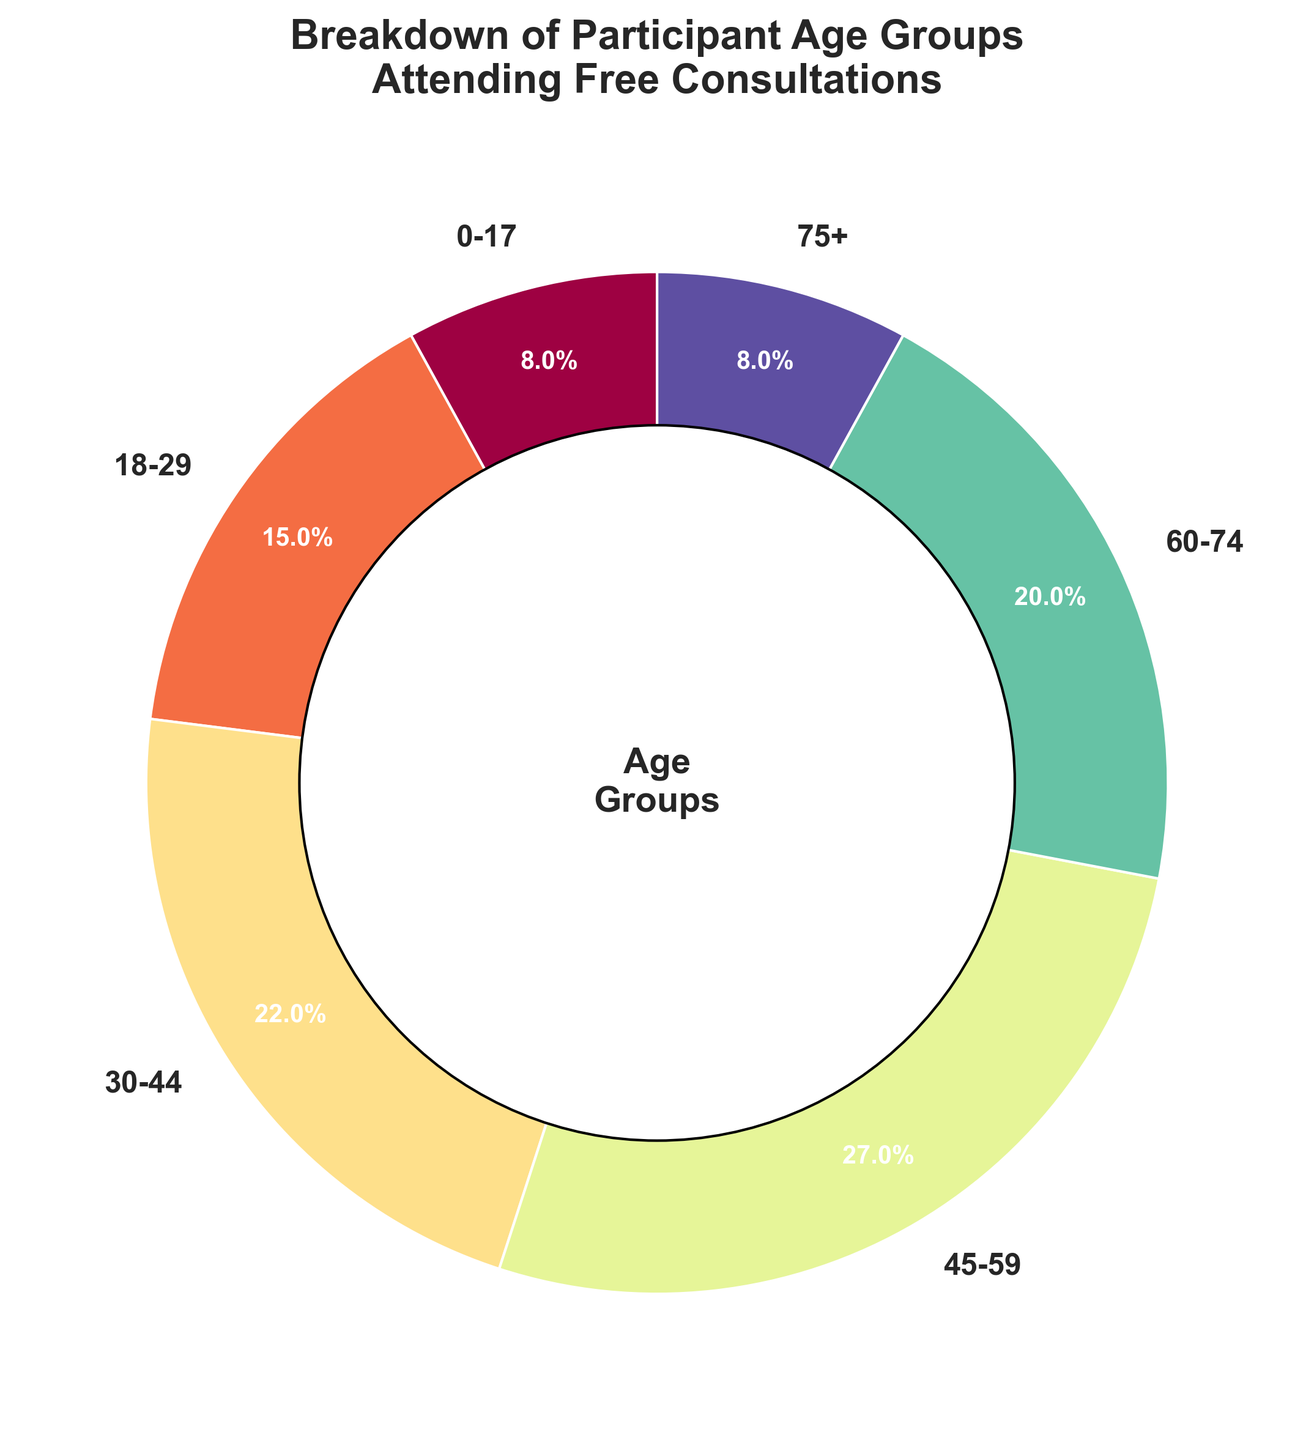What percentage of participants are under 30 years old? Sum the percentages of age groups 0-17 and 18-29. The calculation is 8% + 15% = 23%.
Answer: 23% Which age group has the highest percentage of participants? The age group with the highest percentage is the one with the largest slice of the pie chart. The 45-59 age group has 27%, which is the highest.
Answer: 45-59 Are there more participants in the age group 30-44 or the age group 60-74? Compare the percentages of the age groups 30-44 and 60-74. The 30-44 age group has 22%, whereas the 60-74 age group has 20%.
Answer: 30-44 What is the combined percentage of participants aged 45-74? Sum the percentages of age groups 45-59 and 60-74. The calculation is 27% + 20% = 47%.
Answer: 47% Do age groups 0-17 and 75+ have the same percentage of participants? Check the percentages of both age groups. Both the 0-17 and 75+ age groups have the same percentage, which is 8%.
Answer: Yes Which age group has the smallest percentage of participants? Identify the age group with the smallest slice of the pie chart. Both the 0-17 and 75+ age groups have the smallest percentage at 8%.
Answer: 0-17 and 75+ What is the difference in percentage between the 18-29 and 45-59 age groups? Subtract the percentage of the 18-29 age group from the percentage of the 45-59 age group. The calculation is 27% - 15% = 12%.
Answer: 12% How does the size of the 60-74 age group's slice compare to the size of the 30-44 age group's slice? Compare the sizes visually. The 60-74 age group's slice appears slightly smaller than the 30-44 age group's slice.
Answer: Slightly smaller What percentage of participants are 75 years old or older? The percentage is directly available from the pie chart. The 75+ age group has 8%.
Answer: 8% What is the total percentage of participants aged 18-59? Sum the percentages of age groups 18-29, 30-44, and 45-59. The calculation is 15% + 22% + 27% = 64%.
Answer: 64% 